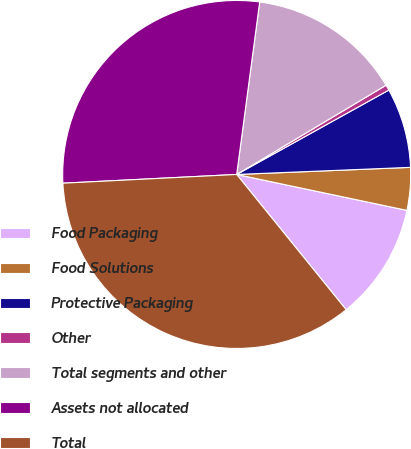Convert chart. <chart><loc_0><loc_0><loc_500><loc_500><pie_chart><fcel>Food Packaging<fcel>Food Solutions<fcel>Protective Packaging<fcel>Other<fcel>Total segments and other<fcel>Assets not allocated<fcel>Total<nl><fcel>10.86%<fcel>3.96%<fcel>7.41%<fcel>0.51%<fcel>14.32%<fcel>27.91%<fcel>35.03%<nl></chart> 